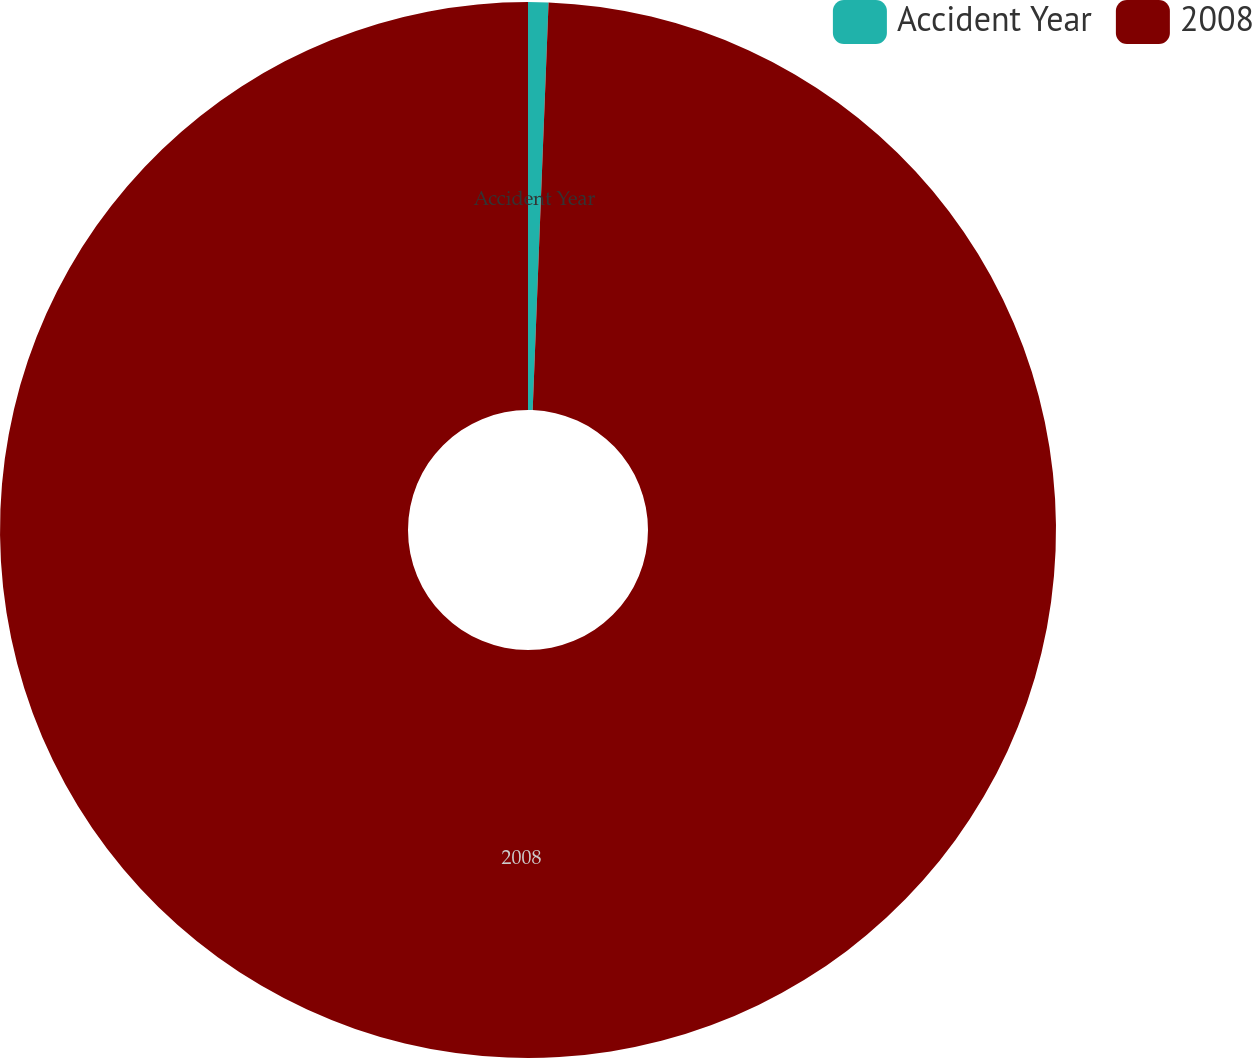Convert chart. <chart><loc_0><loc_0><loc_500><loc_500><pie_chart><fcel>Accident Year<fcel>2008<nl><fcel>0.62%<fcel>99.38%<nl></chart> 